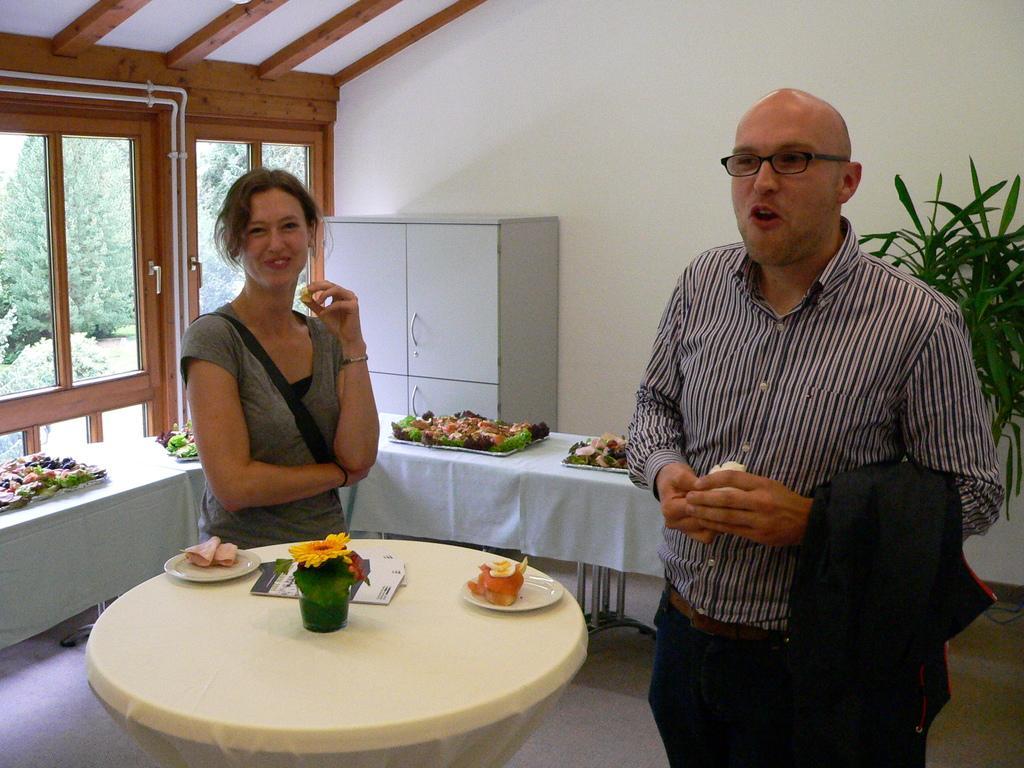Could you give a brief overview of what you see in this image? A woman is standing at the left side and a person is standing at the right side. There is a table at the bottom of image. There is a flower vase, plates having food on it. At the left side there is a door from which trees are visible. There is a wardrobe which is near to the wall. Right side there is a plant. 